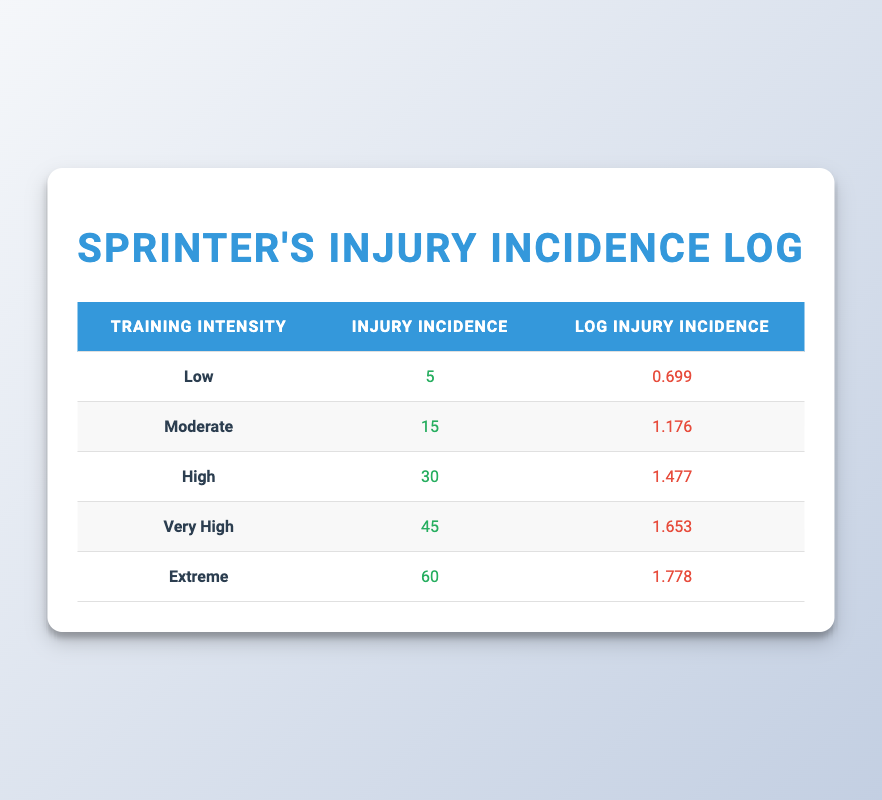What is the injury incidence at extreme training intensity? The table displays the injury incidence values for various training intensities. The extreme intensity level corresponds to an injury incidence of 60.
Answer: 60 What is the logarithmic value of injury incidence at high intensity? According to the table, the log injury incidence value for high training intensity is stated as 1.477.
Answer: 1.477 How many more injuries are reported at very high intensity compared to low intensity? The injury incidence for very high intensity is 45 while for low intensity it is 5. Subtracting 5 from 45 gives 40 more injuries at very high intensity.
Answer: 40 Is the injury incidence higher at moderate intensity than at low intensity? By Comparing the values in the table, the injury incidence for moderate intensity is 15, which is indeed higher than the 5 for low intensity. Therefore, this statement is true.
Answer: Yes What is the average injury incidence across all training intensities? To find the average, first, sum the injury incidences: 5 + 15 + 30 + 45 + 60 = 155. This sum is then divided by the number of intensity levels (5), giving an average of 31.
Answer: 31 How does the injury incidence at high intensity compare with that at very high intensity? The injury incidence for high intensity equals 30, while for very high intensity it equals 45. Clearly, 45 is greater than 30, indicating that injury incidence increases with very high intensity.
Answer: Very High Intensity is greater What is the difference in log injury incidence between extreme and low intensity? The log injury incidence for extreme intensity is 1.778 and for low intensity, it is 0.699. The difference is calculated as 1.778 - 0.699 = 1.079.
Answer: 1.079 Is the trend in injury incidence consistent as intensity increases? Reviewing the table, the injury incidence values continuously rise from low (5) to extreme (60), indicating a consistent upward trend. Thus, the statement is true.
Answer: Yes What is the cumulative injury incidence for all training intensities combined? First, add the injury incidences: 5 + 15 + 30 + 45 + 60 totals to 155. This value represents the cumulative incidence across all intensities.
Answer: 155 